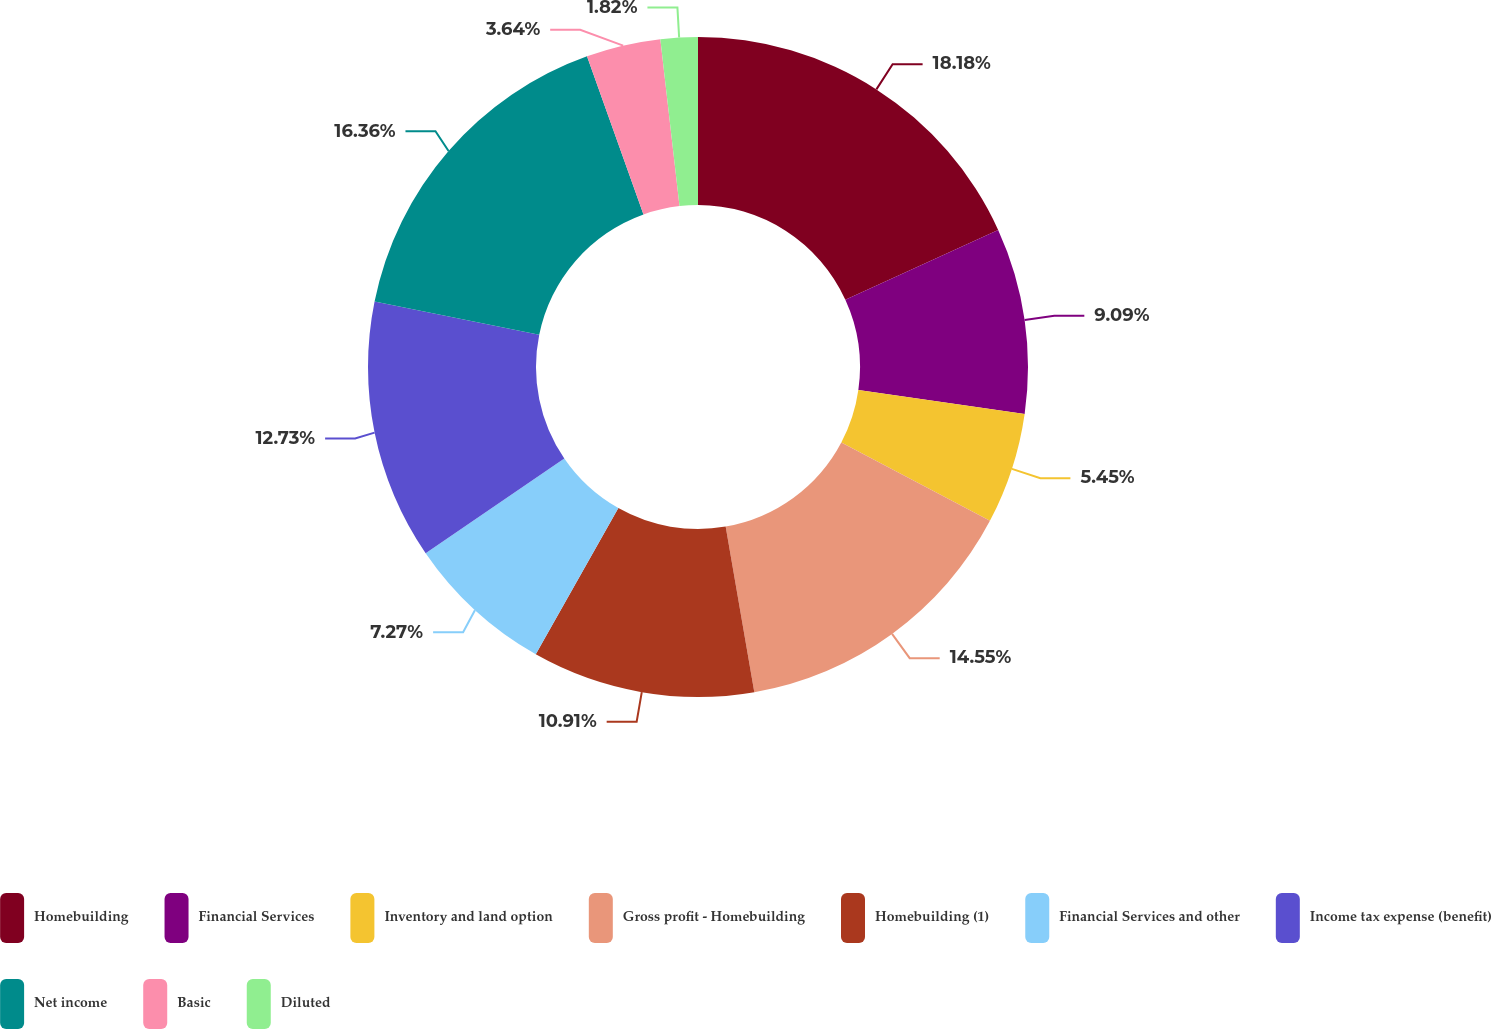Convert chart to OTSL. <chart><loc_0><loc_0><loc_500><loc_500><pie_chart><fcel>Homebuilding<fcel>Financial Services<fcel>Inventory and land option<fcel>Gross profit - Homebuilding<fcel>Homebuilding (1)<fcel>Financial Services and other<fcel>Income tax expense (benefit)<fcel>Net income<fcel>Basic<fcel>Diluted<nl><fcel>18.18%<fcel>9.09%<fcel>5.45%<fcel>14.55%<fcel>10.91%<fcel>7.27%<fcel>12.73%<fcel>16.36%<fcel>3.64%<fcel>1.82%<nl></chart> 